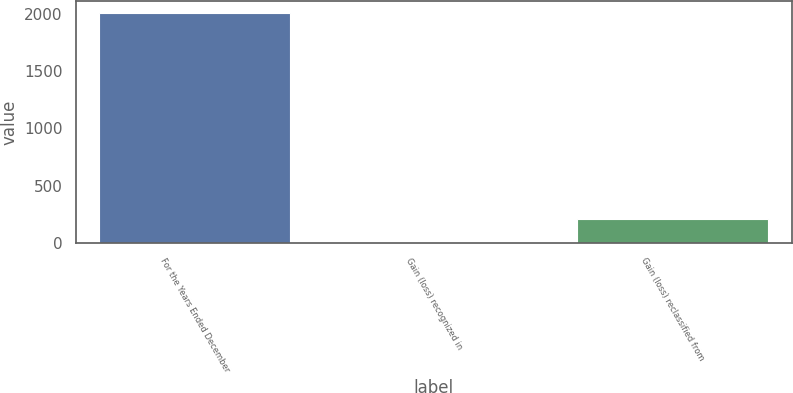Convert chart to OTSL. <chart><loc_0><loc_0><loc_500><loc_500><bar_chart><fcel>For the Years Ended December<fcel>Gain (loss) recognized in<fcel>Gain (loss) reclassified from<nl><fcel>2009<fcel>7<fcel>207.2<nl></chart> 